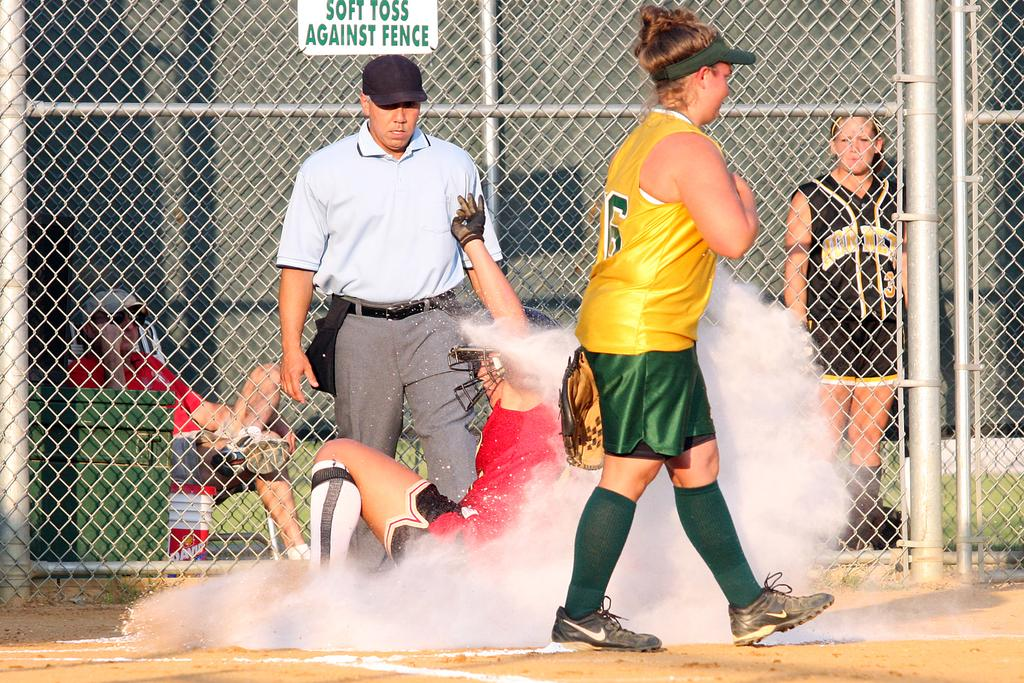<image>
Give a short and clear explanation of the subsequent image. A sign has the phrase soft toss against fence in green lettering. 